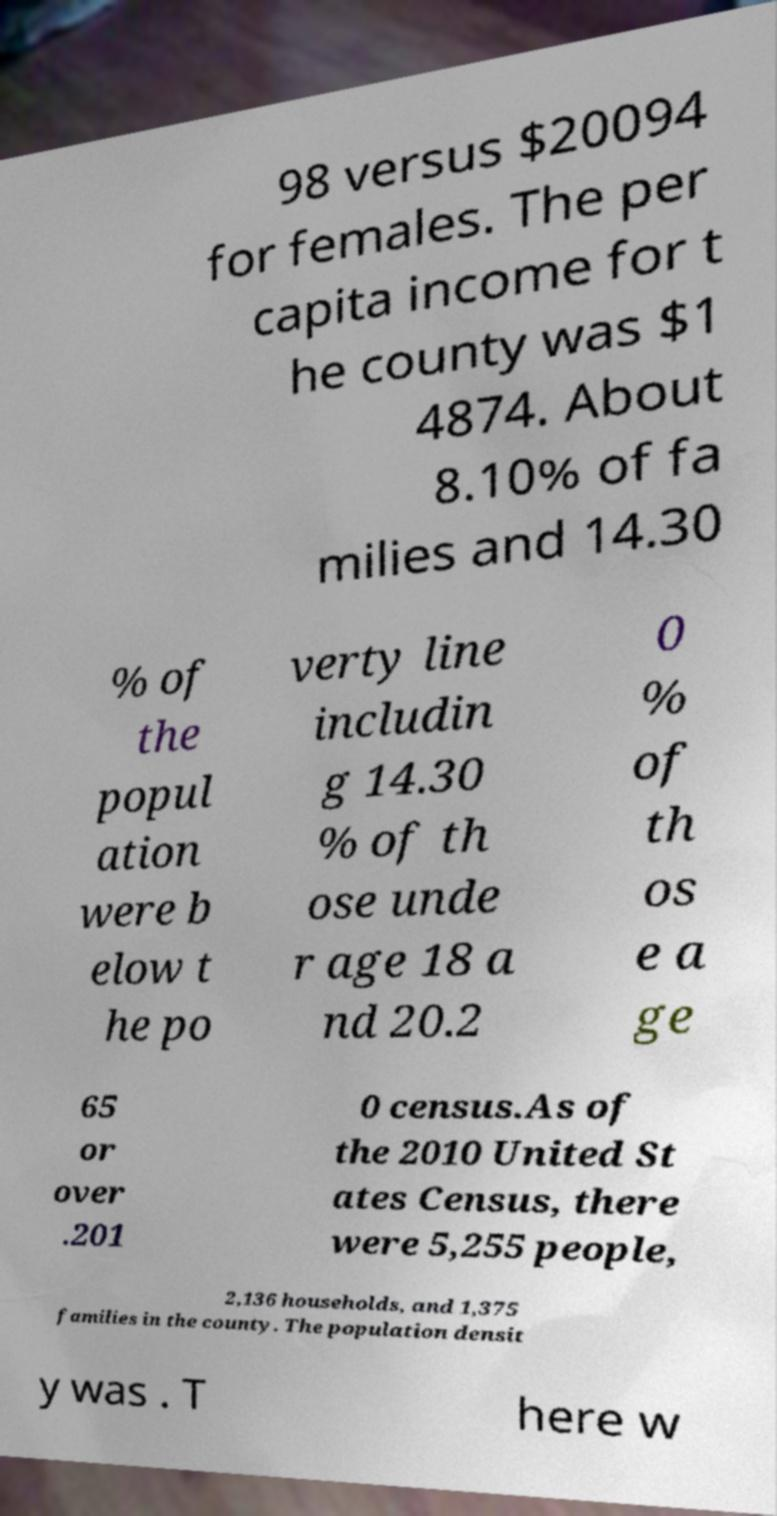Could you assist in decoding the text presented in this image and type it out clearly? 98 versus $20094 for females. The per capita income for t he county was $1 4874. About 8.10% of fa milies and 14.30 % of the popul ation were b elow t he po verty line includin g 14.30 % of th ose unde r age 18 a nd 20.2 0 % of th os e a ge 65 or over .201 0 census.As of the 2010 United St ates Census, there were 5,255 people, 2,136 households, and 1,375 families in the county. The population densit y was . T here w 